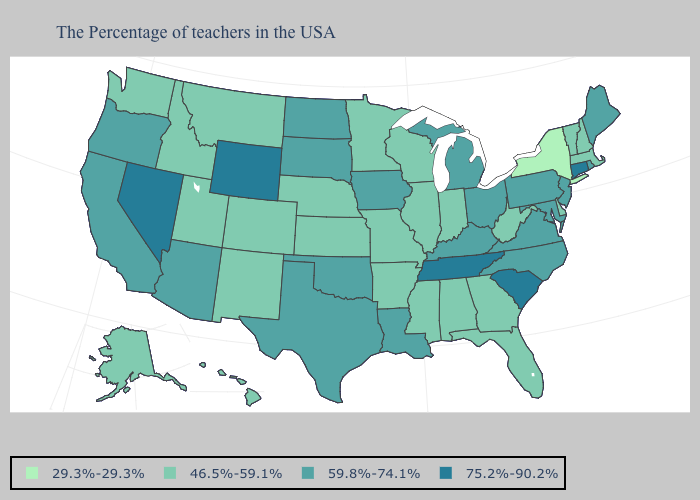What is the value of South Carolina?
Write a very short answer. 75.2%-90.2%. Does New York have the lowest value in the USA?
Concise answer only. Yes. Which states hav the highest value in the MidWest?
Write a very short answer. Ohio, Michigan, Iowa, South Dakota, North Dakota. Does Montana have a higher value than Pennsylvania?
Quick response, please. No. What is the value of South Carolina?
Concise answer only. 75.2%-90.2%. Which states have the lowest value in the Northeast?
Write a very short answer. New York. Which states have the lowest value in the USA?
Keep it brief. New York. What is the value of Indiana?
Answer briefly. 46.5%-59.1%. Does Virginia have a lower value than Nevada?
Give a very brief answer. Yes. What is the highest value in the USA?
Write a very short answer. 75.2%-90.2%. What is the value of Missouri?
Give a very brief answer. 46.5%-59.1%. Among the states that border Oregon , which have the lowest value?
Concise answer only. Idaho, Washington. What is the value of Nebraska?
Be succinct. 46.5%-59.1%. Among the states that border New Hampshire , which have the lowest value?
Keep it brief. Massachusetts, Vermont. 